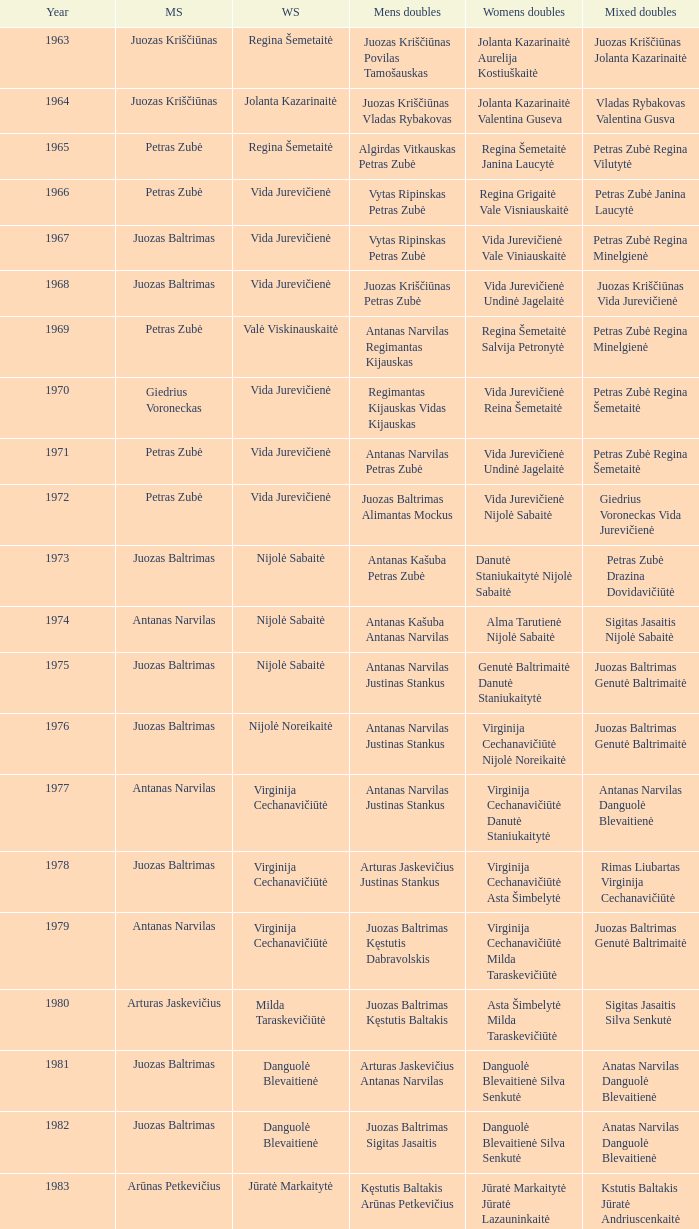How many years did aivaras kvedarauskas juozas spelveris participate in the men's doubles? 1.0. 